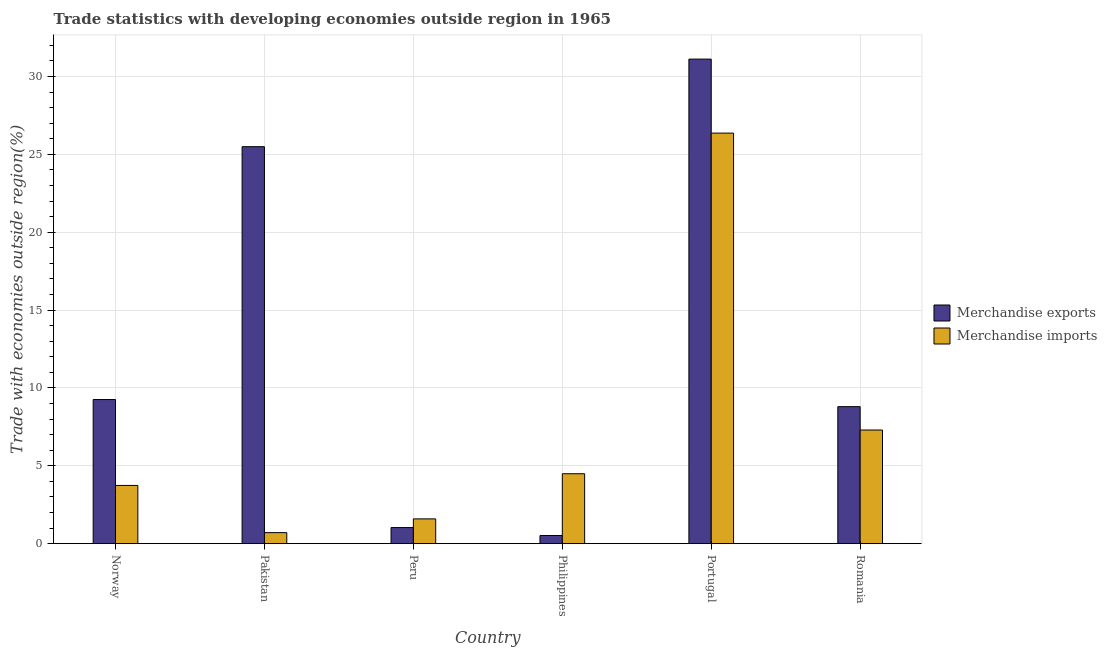Are the number of bars per tick equal to the number of legend labels?
Make the answer very short. Yes. Are the number of bars on each tick of the X-axis equal?
Offer a very short reply. Yes. How many bars are there on the 2nd tick from the left?
Offer a very short reply. 2. How many bars are there on the 3rd tick from the right?
Offer a terse response. 2. What is the label of the 1st group of bars from the left?
Offer a very short reply. Norway. In how many cases, is the number of bars for a given country not equal to the number of legend labels?
Ensure brevity in your answer.  0. What is the merchandise exports in Pakistan?
Give a very brief answer. 25.49. Across all countries, what is the maximum merchandise exports?
Offer a very short reply. 31.12. Across all countries, what is the minimum merchandise exports?
Provide a succinct answer. 0.52. In which country was the merchandise imports maximum?
Make the answer very short. Portugal. In which country was the merchandise exports minimum?
Your answer should be very brief. Philippines. What is the total merchandise imports in the graph?
Your answer should be very brief. 44.19. What is the difference between the merchandise exports in Norway and that in Peru?
Provide a succinct answer. 8.22. What is the difference between the merchandise imports in Romania and the merchandise exports in Pakistan?
Your response must be concise. -18.19. What is the average merchandise imports per country?
Provide a short and direct response. 7.36. What is the difference between the merchandise imports and merchandise exports in Romania?
Keep it short and to the point. -1.5. What is the ratio of the merchandise exports in Norway to that in Portugal?
Offer a terse response. 0.3. What is the difference between the highest and the second highest merchandise exports?
Give a very brief answer. 5.62. What is the difference between the highest and the lowest merchandise exports?
Make the answer very short. 30.59. What does the 1st bar from the right in Norway represents?
Provide a short and direct response. Merchandise imports. How many bars are there?
Keep it short and to the point. 12. How many countries are there in the graph?
Make the answer very short. 6. Does the graph contain any zero values?
Your answer should be very brief. No. Where does the legend appear in the graph?
Provide a succinct answer. Center right. How are the legend labels stacked?
Offer a very short reply. Vertical. What is the title of the graph?
Your answer should be very brief. Trade statistics with developing economies outside region in 1965. Does "From human activities" appear as one of the legend labels in the graph?
Provide a succinct answer. No. What is the label or title of the Y-axis?
Provide a short and direct response. Trade with economies outside region(%). What is the Trade with economies outside region(%) of Merchandise exports in Norway?
Keep it short and to the point. 9.25. What is the Trade with economies outside region(%) of Merchandise imports in Norway?
Offer a very short reply. 3.74. What is the Trade with economies outside region(%) of Merchandise exports in Pakistan?
Offer a very short reply. 25.49. What is the Trade with economies outside region(%) in Merchandise imports in Pakistan?
Provide a short and direct response. 0.71. What is the Trade with economies outside region(%) in Merchandise exports in Peru?
Your answer should be compact. 1.03. What is the Trade with economies outside region(%) in Merchandise imports in Peru?
Ensure brevity in your answer.  1.59. What is the Trade with economies outside region(%) in Merchandise exports in Philippines?
Make the answer very short. 0.52. What is the Trade with economies outside region(%) of Merchandise imports in Philippines?
Ensure brevity in your answer.  4.49. What is the Trade with economies outside region(%) of Merchandise exports in Portugal?
Your answer should be very brief. 31.12. What is the Trade with economies outside region(%) of Merchandise imports in Portugal?
Your answer should be very brief. 26.36. What is the Trade with economies outside region(%) of Merchandise exports in Romania?
Your answer should be compact. 8.8. What is the Trade with economies outside region(%) in Merchandise imports in Romania?
Keep it short and to the point. 7.3. Across all countries, what is the maximum Trade with economies outside region(%) of Merchandise exports?
Keep it short and to the point. 31.12. Across all countries, what is the maximum Trade with economies outside region(%) in Merchandise imports?
Ensure brevity in your answer.  26.36. Across all countries, what is the minimum Trade with economies outside region(%) of Merchandise exports?
Your answer should be very brief. 0.52. Across all countries, what is the minimum Trade with economies outside region(%) in Merchandise imports?
Give a very brief answer. 0.71. What is the total Trade with economies outside region(%) of Merchandise exports in the graph?
Your answer should be very brief. 76.22. What is the total Trade with economies outside region(%) of Merchandise imports in the graph?
Keep it short and to the point. 44.19. What is the difference between the Trade with economies outside region(%) of Merchandise exports in Norway and that in Pakistan?
Your answer should be compact. -16.24. What is the difference between the Trade with economies outside region(%) in Merchandise imports in Norway and that in Pakistan?
Your answer should be compact. 3.03. What is the difference between the Trade with economies outside region(%) in Merchandise exports in Norway and that in Peru?
Your response must be concise. 8.22. What is the difference between the Trade with economies outside region(%) in Merchandise imports in Norway and that in Peru?
Offer a very short reply. 2.15. What is the difference between the Trade with economies outside region(%) in Merchandise exports in Norway and that in Philippines?
Your answer should be compact. 8.73. What is the difference between the Trade with economies outside region(%) of Merchandise imports in Norway and that in Philippines?
Your response must be concise. -0.75. What is the difference between the Trade with economies outside region(%) in Merchandise exports in Norway and that in Portugal?
Offer a terse response. -21.86. What is the difference between the Trade with economies outside region(%) in Merchandise imports in Norway and that in Portugal?
Your response must be concise. -22.62. What is the difference between the Trade with economies outside region(%) in Merchandise exports in Norway and that in Romania?
Provide a succinct answer. 0.46. What is the difference between the Trade with economies outside region(%) in Merchandise imports in Norway and that in Romania?
Your response must be concise. -3.56. What is the difference between the Trade with economies outside region(%) of Merchandise exports in Pakistan and that in Peru?
Your response must be concise. 24.46. What is the difference between the Trade with economies outside region(%) of Merchandise imports in Pakistan and that in Peru?
Make the answer very short. -0.88. What is the difference between the Trade with economies outside region(%) of Merchandise exports in Pakistan and that in Philippines?
Offer a very short reply. 24.97. What is the difference between the Trade with economies outside region(%) in Merchandise imports in Pakistan and that in Philippines?
Offer a very short reply. -3.78. What is the difference between the Trade with economies outside region(%) of Merchandise exports in Pakistan and that in Portugal?
Offer a terse response. -5.62. What is the difference between the Trade with economies outside region(%) in Merchandise imports in Pakistan and that in Portugal?
Your answer should be very brief. -25.65. What is the difference between the Trade with economies outside region(%) of Merchandise exports in Pakistan and that in Romania?
Offer a terse response. 16.69. What is the difference between the Trade with economies outside region(%) of Merchandise imports in Pakistan and that in Romania?
Give a very brief answer. -6.59. What is the difference between the Trade with economies outside region(%) in Merchandise exports in Peru and that in Philippines?
Make the answer very short. 0.51. What is the difference between the Trade with economies outside region(%) in Merchandise imports in Peru and that in Philippines?
Give a very brief answer. -2.9. What is the difference between the Trade with economies outside region(%) of Merchandise exports in Peru and that in Portugal?
Ensure brevity in your answer.  -30.08. What is the difference between the Trade with economies outside region(%) of Merchandise imports in Peru and that in Portugal?
Make the answer very short. -24.77. What is the difference between the Trade with economies outside region(%) in Merchandise exports in Peru and that in Romania?
Provide a short and direct response. -7.76. What is the difference between the Trade with economies outside region(%) of Merchandise imports in Peru and that in Romania?
Offer a terse response. -5.71. What is the difference between the Trade with economies outside region(%) of Merchandise exports in Philippines and that in Portugal?
Give a very brief answer. -30.59. What is the difference between the Trade with economies outside region(%) of Merchandise imports in Philippines and that in Portugal?
Offer a very short reply. -21.87. What is the difference between the Trade with economies outside region(%) of Merchandise exports in Philippines and that in Romania?
Provide a short and direct response. -8.27. What is the difference between the Trade with economies outside region(%) of Merchandise imports in Philippines and that in Romania?
Your answer should be very brief. -2.81. What is the difference between the Trade with economies outside region(%) of Merchandise exports in Portugal and that in Romania?
Ensure brevity in your answer.  22.32. What is the difference between the Trade with economies outside region(%) in Merchandise imports in Portugal and that in Romania?
Your answer should be compact. 19.07. What is the difference between the Trade with economies outside region(%) in Merchandise exports in Norway and the Trade with economies outside region(%) in Merchandise imports in Pakistan?
Offer a very short reply. 8.55. What is the difference between the Trade with economies outside region(%) in Merchandise exports in Norway and the Trade with economies outside region(%) in Merchandise imports in Peru?
Your response must be concise. 7.66. What is the difference between the Trade with economies outside region(%) in Merchandise exports in Norway and the Trade with economies outside region(%) in Merchandise imports in Philippines?
Give a very brief answer. 4.76. What is the difference between the Trade with economies outside region(%) in Merchandise exports in Norway and the Trade with economies outside region(%) in Merchandise imports in Portugal?
Your answer should be very brief. -17.11. What is the difference between the Trade with economies outside region(%) of Merchandise exports in Norway and the Trade with economies outside region(%) of Merchandise imports in Romania?
Provide a succinct answer. 1.96. What is the difference between the Trade with economies outside region(%) in Merchandise exports in Pakistan and the Trade with economies outside region(%) in Merchandise imports in Peru?
Keep it short and to the point. 23.9. What is the difference between the Trade with economies outside region(%) of Merchandise exports in Pakistan and the Trade with economies outside region(%) of Merchandise imports in Philippines?
Make the answer very short. 21. What is the difference between the Trade with economies outside region(%) in Merchandise exports in Pakistan and the Trade with economies outside region(%) in Merchandise imports in Portugal?
Ensure brevity in your answer.  -0.87. What is the difference between the Trade with economies outside region(%) in Merchandise exports in Pakistan and the Trade with economies outside region(%) in Merchandise imports in Romania?
Ensure brevity in your answer.  18.19. What is the difference between the Trade with economies outside region(%) of Merchandise exports in Peru and the Trade with economies outside region(%) of Merchandise imports in Philippines?
Your answer should be very brief. -3.46. What is the difference between the Trade with economies outside region(%) in Merchandise exports in Peru and the Trade with economies outside region(%) in Merchandise imports in Portugal?
Your answer should be very brief. -25.33. What is the difference between the Trade with economies outside region(%) of Merchandise exports in Peru and the Trade with economies outside region(%) of Merchandise imports in Romania?
Give a very brief answer. -6.26. What is the difference between the Trade with economies outside region(%) of Merchandise exports in Philippines and the Trade with economies outside region(%) of Merchandise imports in Portugal?
Make the answer very short. -25.84. What is the difference between the Trade with economies outside region(%) in Merchandise exports in Philippines and the Trade with economies outside region(%) in Merchandise imports in Romania?
Offer a terse response. -6.77. What is the difference between the Trade with economies outside region(%) of Merchandise exports in Portugal and the Trade with economies outside region(%) of Merchandise imports in Romania?
Make the answer very short. 23.82. What is the average Trade with economies outside region(%) of Merchandise exports per country?
Provide a succinct answer. 12.7. What is the average Trade with economies outside region(%) of Merchandise imports per country?
Your response must be concise. 7.36. What is the difference between the Trade with economies outside region(%) of Merchandise exports and Trade with economies outside region(%) of Merchandise imports in Norway?
Your answer should be compact. 5.52. What is the difference between the Trade with economies outside region(%) in Merchandise exports and Trade with economies outside region(%) in Merchandise imports in Pakistan?
Your response must be concise. 24.78. What is the difference between the Trade with economies outside region(%) in Merchandise exports and Trade with economies outside region(%) in Merchandise imports in Peru?
Ensure brevity in your answer.  -0.56. What is the difference between the Trade with economies outside region(%) of Merchandise exports and Trade with economies outside region(%) of Merchandise imports in Philippines?
Offer a terse response. -3.97. What is the difference between the Trade with economies outside region(%) in Merchandise exports and Trade with economies outside region(%) in Merchandise imports in Portugal?
Provide a short and direct response. 4.75. What is the ratio of the Trade with economies outside region(%) in Merchandise exports in Norway to that in Pakistan?
Your answer should be very brief. 0.36. What is the ratio of the Trade with economies outside region(%) of Merchandise imports in Norway to that in Pakistan?
Offer a terse response. 5.28. What is the ratio of the Trade with economies outside region(%) of Merchandise exports in Norway to that in Peru?
Your answer should be compact. 8.95. What is the ratio of the Trade with economies outside region(%) of Merchandise imports in Norway to that in Peru?
Your answer should be very brief. 2.35. What is the ratio of the Trade with economies outside region(%) of Merchandise exports in Norway to that in Philippines?
Offer a terse response. 17.66. What is the ratio of the Trade with economies outside region(%) of Merchandise imports in Norway to that in Philippines?
Your response must be concise. 0.83. What is the ratio of the Trade with economies outside region(%) in Merchandise exports in Norway to that in Portugal?
Provide a succinct answer. 0.3. What is the ratio of the Trade with economies outside region(%) of Merchandise imports in Norway to that in Portugal?
Make the answer very short. 0.14. What is the ratio of the Trade with economies outside region(%) in Merchandise exports in Norway to that in Romania?
Your response must be concise. 1.05. What is the ratio of the Trade with economies outside region(%) of Merchandise imports in Norway to that in Romania?
Your answer should be very brief. 0.51. What is the ratio of the Trade with economies outside region(%) of Merchandise exports in Pakistan to that in Peru?
Provide a short and direct response. 24.66. What is the ratio of the Trade with economies outside region(%) in Merchandise imports in Pakistan to that in Peru?
Your response must be concise. 0.44. What is the ratio of the Trade with economies outside region(%) in Merchandise exports in Pakistan to that in Philippines?
Ensure brevity in your answer.  48.63. What is the ratio of the Trade with economies outside region(%) in Merchandise imports in Pakistan to that in Philippines?
Offer a terse response. 0.16. What is the ratio of the Trade with economies outside region(%) of Merchandise exports in Pakistan to that in Portugal?
Offer a very short reply. 0.82. What is the ratio of the Trade with economies outside region(%) of Merchandise imports in Pakistan to that in Portugal?
Provide a succinct answer. 0.03. What is the ratio of the Trade with economies outside region(%) in Merchandise exports in Pakistan to that in Romania?
Provide a short and direct response. 2.9. What is the ratio of the Trade with economies outside region(%) of Merchandise imports in Pakistan to that in Romania?
Give a very brief answer. 0.1. What is the ratio of the Trade with economies outside region(%) in Merchandise exports in Peru to that in Philippines?
Give a very brief answer. 1.97. What is the ratio of the Trade with economies outside region(%) in Merchandise imports in Peru to that in Philippines?
Provide a short and direct response. 0.35. What is the ratio of the Trade with economies outside region(%) of Merchandise exports in Peru to that in Portugal?
Offer a terse response. 0.03. What is the ratio of the Trade with economies outside region(%) of Merchandise imports in Peru to that in Portugal?
Keep it short and to the point. 0.06. What is the ratio of the Trade with economies outside region(%) in Merchandise exports in Peru to that in Romania?
Keep it short and to the point. 0.12. What is the ratio of the Trade with economies outside region(%) of Merchandise imports in Peru to that in Romania?
Offer a terse response. 0.22. What is the ratio of the Trade with economies outside region(%) in Merchandise exports in Philippines to that in Portugal?
Your response must be concise. 0.02. What is the ratio of the Trade with economies outside region(%) of Merchandise imports in Philippines to that in Portugal?
Make the answer very short. 0.17. What is the ratio of the Trade with economies outside region(%) in Merchandise exports in Philippines to that in Romania?
Your answer should be compact. 0.06. What is the ratio of the Trade with economies outside region(%) of Merchandise imports in Philippines to that in Romania?
Keep it short and to the point. 0.62. What is the ratio of the Trade with economies outside region(%) of Merchandise exports in Portugal to that in Romania?
Provide a short and direct response. 3.54. What is the ratio of the Trade with economies outside region(%) in Merchandise imports in Portugal to that in Romania?
Offer a terse response. 3.61. What is the difference between the highest and the second highest Trade with economies outside region(%) of Merchandise exports?
Provide a succinct answer. 5.62. What is the difference between the highest and the second highest Trade with economies outside region(%) of Merchandise imports?
Make the answer very short. 19.07. What is the difference between the highest and the lowest Trade with economies outside region(%) of Merchandise exports?
Make the answer very short. 30.59. What is the difference between the highest and the lowest Trade with economies outside region(%) of Merchandise imports?
Your answer should be very brief. 25.65. 